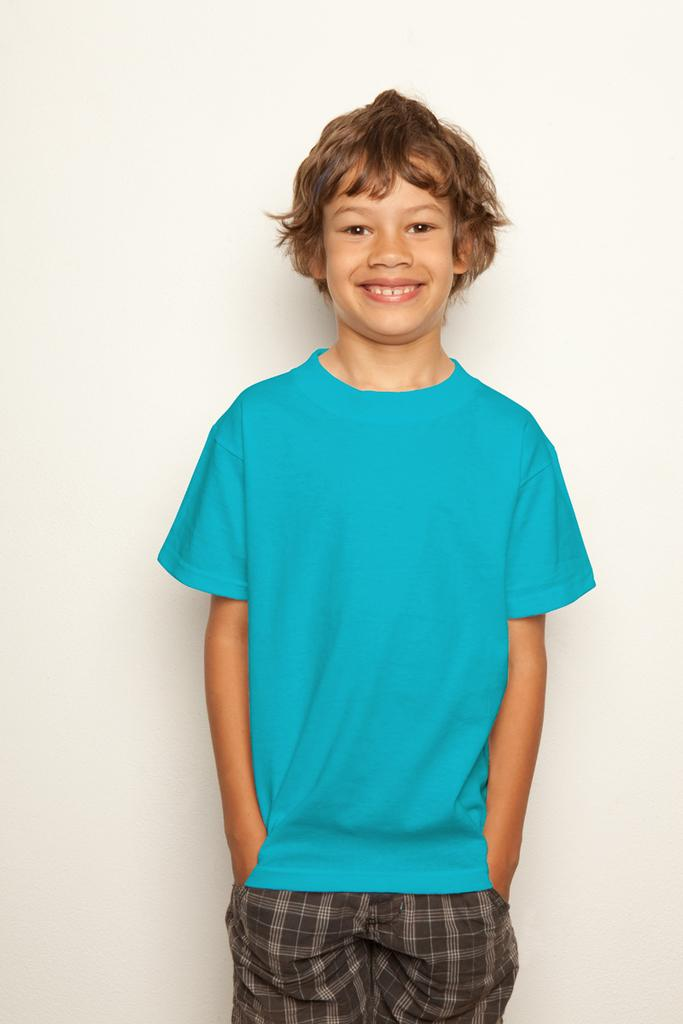What is the main subject of the image? There is a person in the image. Can you describe the setting or environment in the image? There is a background visible in the image. What type of legal advice is the person providing in the image? There is no indication in the image that the person is a lawyer or providing any legal advice. 